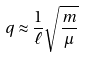<formula> <loc_0><loc_0><loc_500><loc_500>q \approx \frac { 1 } { \ell } \sqrt { \frac { m } { \mu } }</formula> 